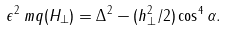<formula> <loc_0><loc_0><loc_500><loc_500>\epsilon ^ { 2 } _ { \ } m q ( H _ { \perp } ) = \Delta ^ { 2 } - ( h ^ { 2 } _ { \perp } / 2 ) \cos ^ { 4 } \alpha .</formula> 